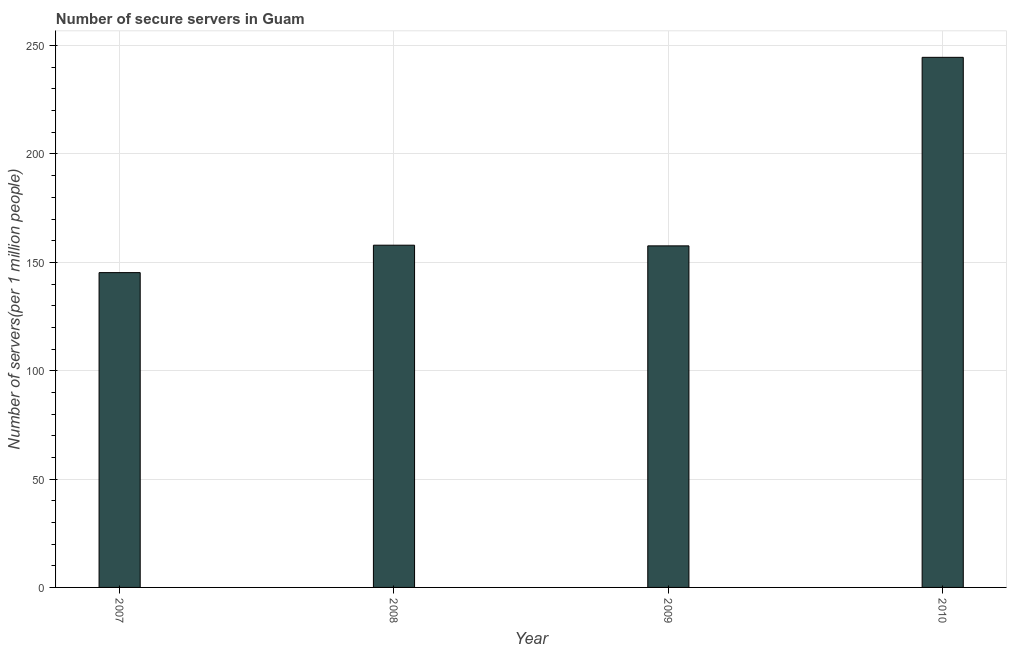What is the title of the graph?
Your answer should be compact. Number of secure servers in Guam. What is the label or title of the Y-axis?
Your answer should be compact. Number of servers(per 1 million people). What is the number of secure internet servers in 2010?
Offer a very short reply. 244.61. Across all years, what is the maximum number of secure internet servers?
Make the answer very short. 244.61. Across all years, what is the minimum number of secure internet servers?
Make the answer very short. 145.26. In which year was the number of secure internet servers maximum?
Offer a terse response. 2010. In which year was the number of secure internet servers minimum?
Your answer should be very brief. 2007. What is the sum of the number of secure internet servers?
Your response must be concise. 705.4. What is the difference between the number of secure internet servers in 2007 and 2010?
Your response must be concise. -99.34. What is the average number of secure internet servers per year?
Provide a short and direct response. 176.35. What is the median number of secure internet servers?
Provide a succinct answer. 157.76. Do a majority of the years between 2008 and 2009 (inclusive) have number of secure internet servers greater than 190 ?
Offer a terse response. No. What is the ratio of the number of secure internet servers in 2007 to that in 2010?
Offer a terse response. 0.59. Is the number of secure internet servers in 2007 less than that in 2010?
Offer a very short reply. Yes. What is the difference between the highest and the second highest number of secure internet servers?
Give a very brief answer. 86.69. What is the difference between the highest and the lowest number of secure internet servers?
Offer a terse response. 99.34. In how many years, is the number of secure internet servers greater than the average number of secure internet servers taken over all years?
Your answer should be compact. 1. How many bars are there?
Provide a succinct answer. 4. How many years are there in the graph?
Keep it short and to the point. 4. What is the difference between two consecutive major ticks on the Y-axis?
Your response must be concise. 50. Are the values on the major ticks of Y-axis written in scientific E-notation?
Offer a terse response. No. What is the Number of servers(per 1 million people) in 2007?
Ensure brevity in your answer.  145.26. What is the Number of servers(per 1 million people) of 2008?
Provide a short and direct response. 157.92. What is the Number of servers(per 1 million people) in 2009?
Offer a terse response. 157.61. What is the Number of servers(per 1 million people) in 2010?
Provide a short and direct response. 244.61. What is the difference between the Number of servers(per 1 million people) in 2007 and 2008?
Provide a short and direct response. -12.65. What is the difference between the Number of servers(per 1 million people) in 2007 and 2009?
Make the answer very short. -12.34. What is the difference between the Number of servers(per 1 million people) in 2007 and 2010?
Your response must be concise. -99.34. What is the difference between the Number of servers(per 1 million people) in 2008 and 2009?
Provide a succinct answer. 0.31. What is the difference between the Number of servers(per 1 million people) in 2008 and 2010?
Provide a succinct answer. -86.69. What is the difference between the Number of servers(per 1 million people) in 2009 and 2010?
Offer a terse response. -87. What is the ratio of the Number of servers(per 1 million people) in 2007 to that in 2008?
Your answer should be compact. 0.92. What is the ratio of the Number of servers(per 1 million people) in 2007 to that in 2009?
Your answer should be compact. 0.92. What is the ratio of the Number of servers(per 1 million people) in 2007 to that in 2010?
Provide a succinct answer. 0.59. What is the ratio of the Number of servers(per 1 million people) in 2008 to that in 2010?
Make the answer very short. 0.65. What is the ratio of the Number of servers(per 1 million people) in 2009 to that in 2010?
Offer a terse response. 0.64. 